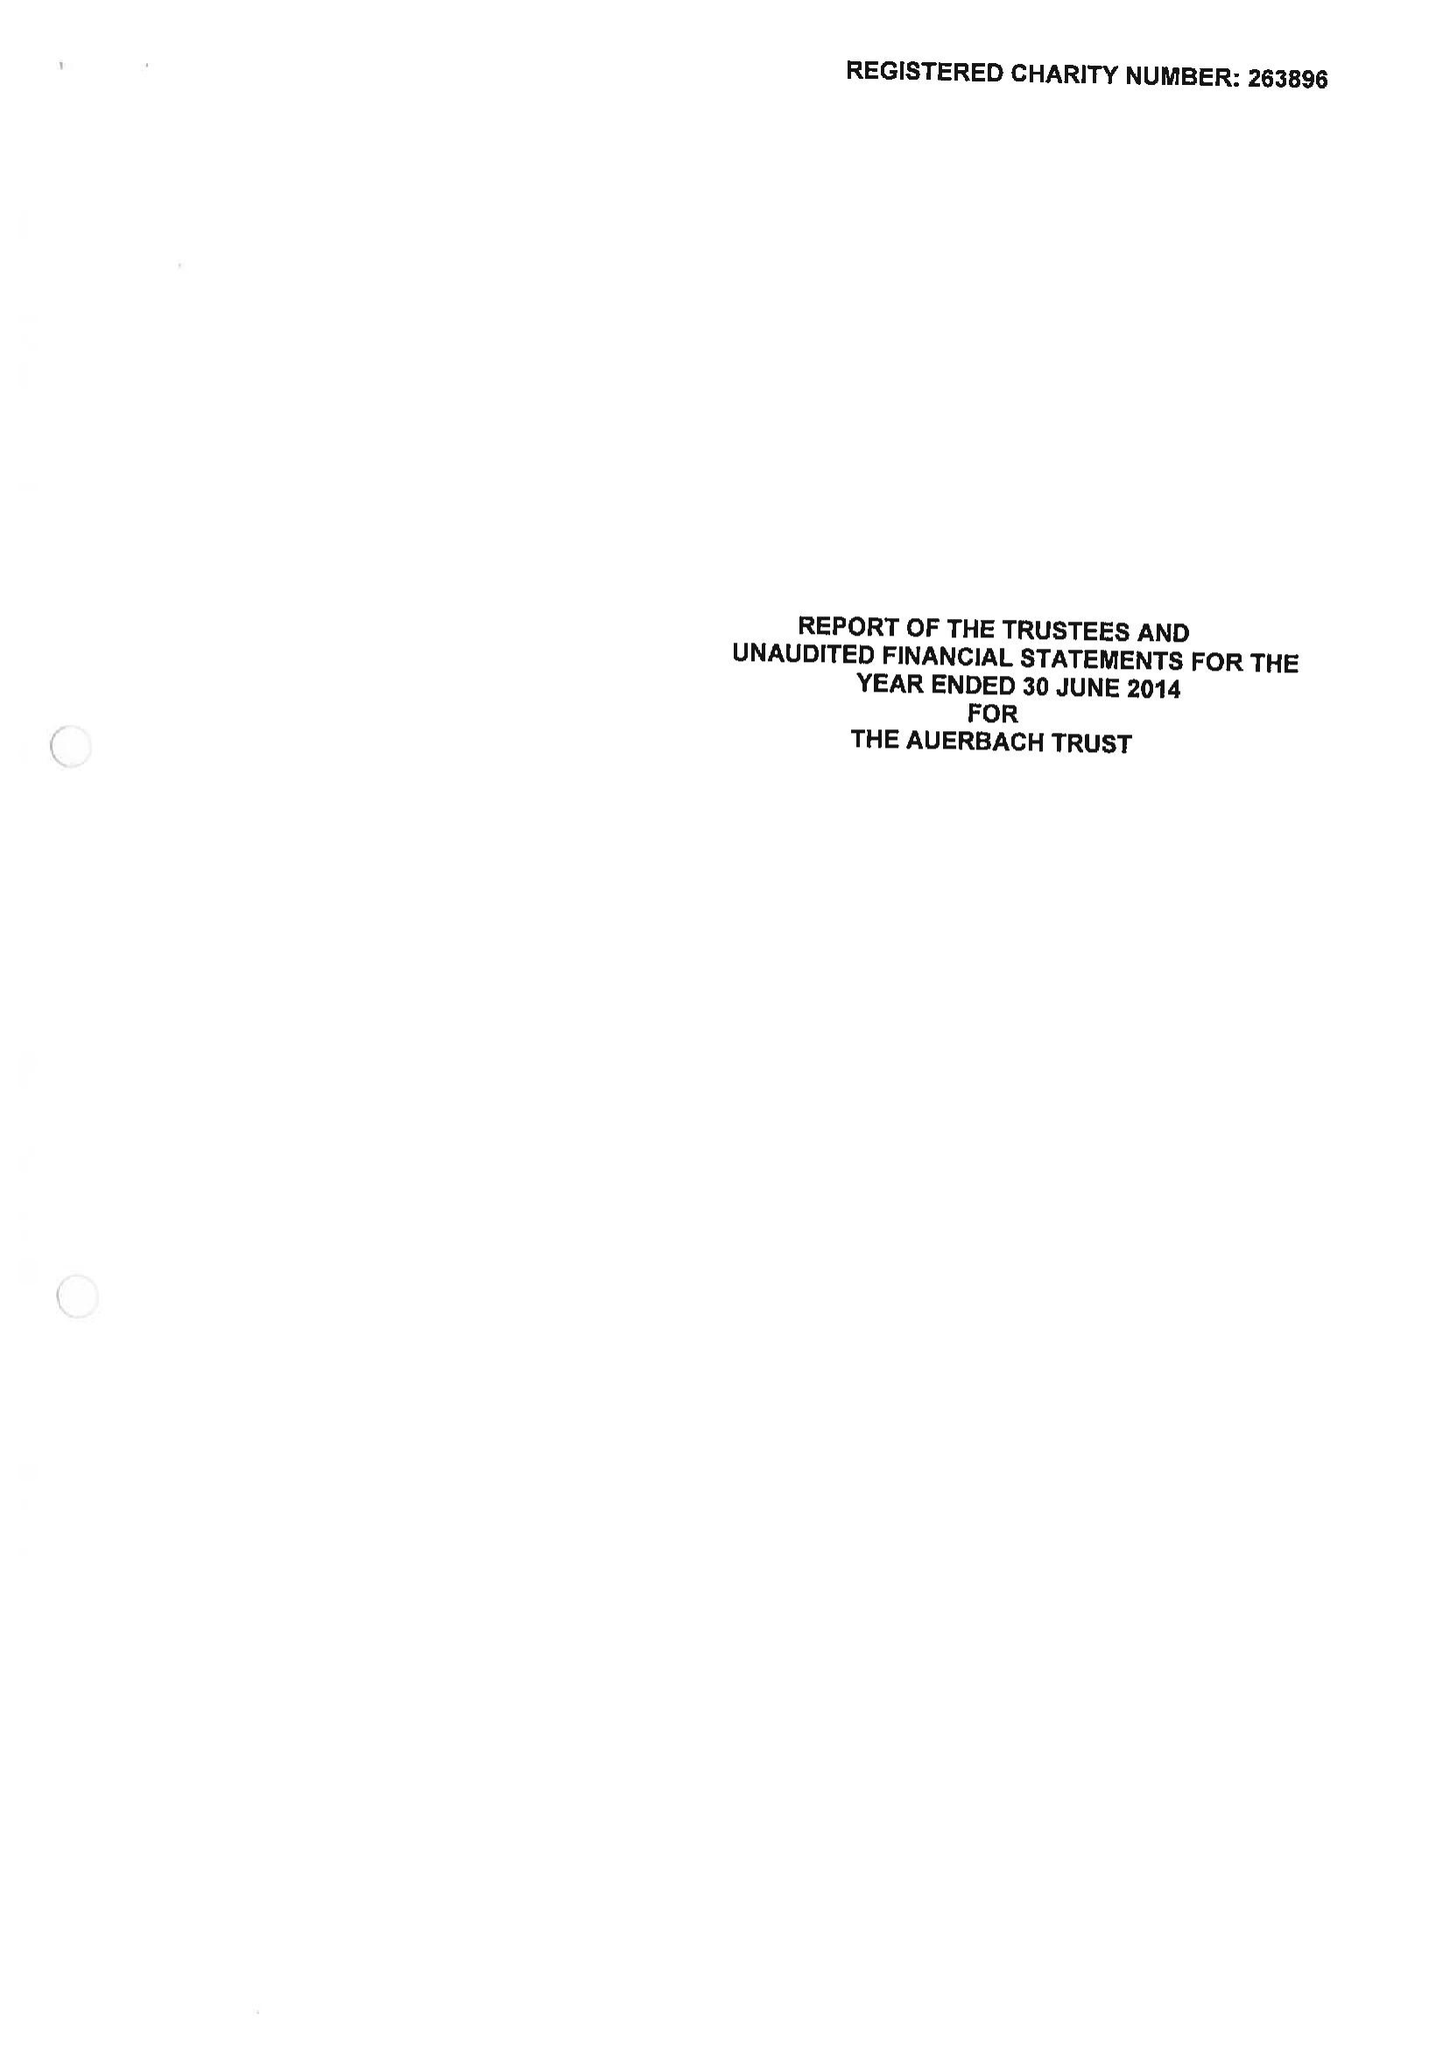What is the value for the charity_name?
Answer the question using a single word or phrase. The Auerbach Trust 